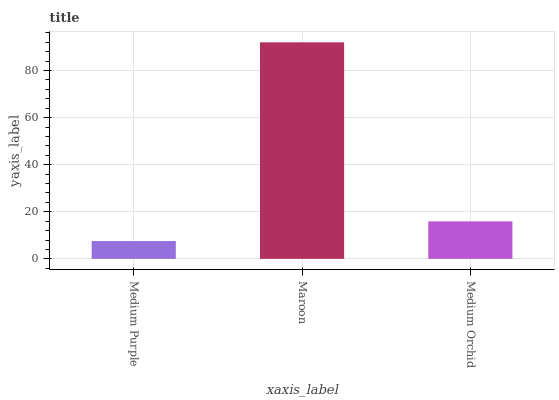Is Medium Purple the minimum?
Answer yes or no. Yes. Is Maroon the maximum?
Answer yes or no. Yes. Is Medium Orchid the minimum?
Answer yes or no. No. Is Medium Orchid the maximum?
Answer yes or no. No. Is Maroon greater than Medium Orchid?
Answer yes or no. Yes. Is Medium Orchid less than Maroon?
Answer yes or no. Yes. Is Medium Orchid greater than Maroon?
Answer yes or no. No. Is Maroon less than Medium Orchid?
Answer yes or no. No. Is Medium Orchid the high median?
Answer yes or no. Yes. Is Medium Orchid the low median?
Answer yes or no. Yes. Is Maroon the high median?
Answer yes or no. No. Is Medium Purple the low median?
Answer yes or no. No. 